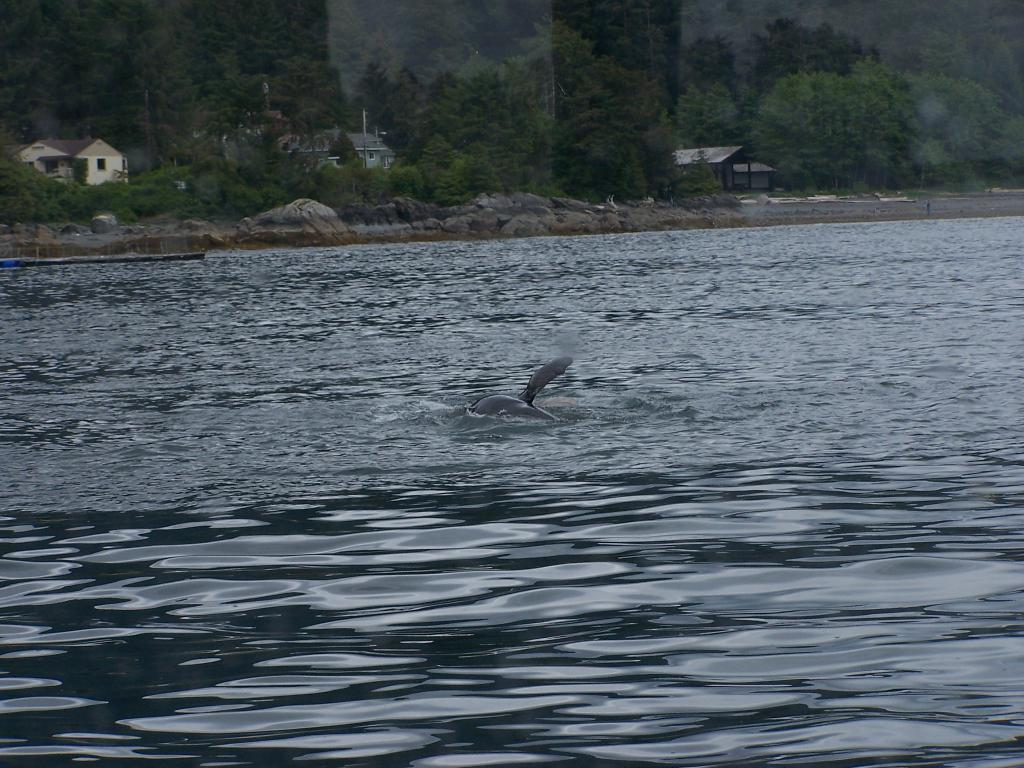What is the main subject in the center of the image? There is water in the center of the image. What type of creature can be seen in the water? There is an aquatic animal in the water. What can be seen in the background of the image? There are trees and houses in the background of the image. What type of surface is visible in the image? There are stones visible in the image. Where is the bomb located in the image? There is no bomb present in the image. How many cherries are on the aquatic animal in the image? There are no cherries present in the image, and the aquatic animal is not carrying any cherries. 